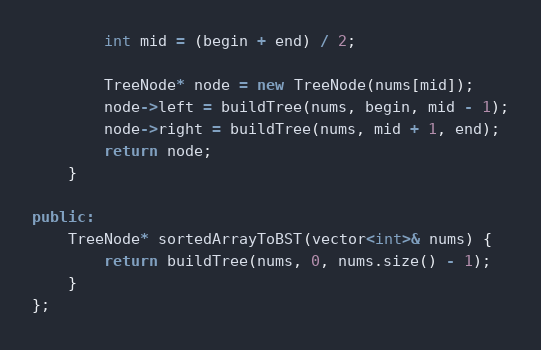<code> <loc_0><loc_0><loc_500><loc_500><_C++_>        int mid = (begin + end) / 2;
        
        TreeNode* node = new TreeNode(nums[mid]);
        node->left = buildTree(nums, begin, mid - 1);
        node->right = buildTree(nums, mid + 1, end);
        return node;
    }
    
public:
    TreeNode* sortedArrayToBST(vector<int>& nums) {
        return buildTree(nums, 0, nums.size() - 1);
    }
};
</code> 